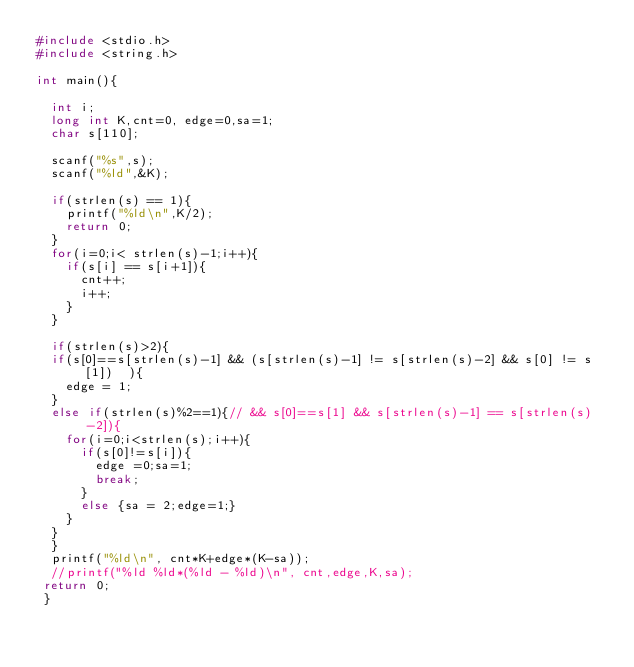Convert code to text. <code><loc_0><loc_0><loc_500><loc_500><_C_>#include <stdio.h>
#include <string.h>

int main(){

	int i;
	long int K,cnt=0, edge=0,sa=1;
	char s[110];
	
	scanf("%s",s);
	scanf("%ld",&K);
	
	if(strlen(s) == 1){
		printf("%ld\n",K/2);
		return 0;
	}
	for(i=0;i< strlen(s)-1;i++){
		if(s[i] == s[i+1]){
			cnt++;
			i++;
		}
	}
	
	if(strlen(s)>2){
	if(s[0]==s[strlen(s)-1] && (s[strlen(s)-1] != s[strlen(s)-2] && s[0] != s[1])  ){
		edge = 1;
	}
	else if(strlen(s)%2==1){// && s[0]==s[1] && s[strlen(s)-1] == s[strlen(s)-2]){
		for(i=0;i<strlen(s);i++){
			if(s[0]!=s[i]){
				edge =0;sa=1;
				break;
			}
			else {sa = 2;edge=1;}
		}
	}
	}
	printf("%ld\n", cnt*K+edge*(K-sa));
	//printf("%ld %ld*(%ld - %ld)\n", cnt,edge,K,sa);
 return 0;
 }</code> 